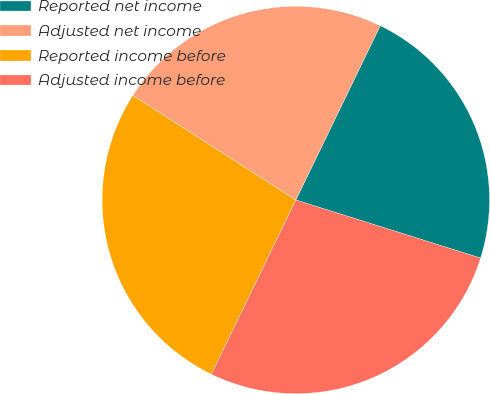<chart> <loc_0><loc_0><loc_500><loc_500><pie_chart><fcel>Reported net income<fcel>Adjusted net income<fcel>Reported income before<fcel>Adjusted income before<nl><fcel>22.67%<fcel>23.1%<fcel>26.9%<fcel>27.33%<nl></chart> 